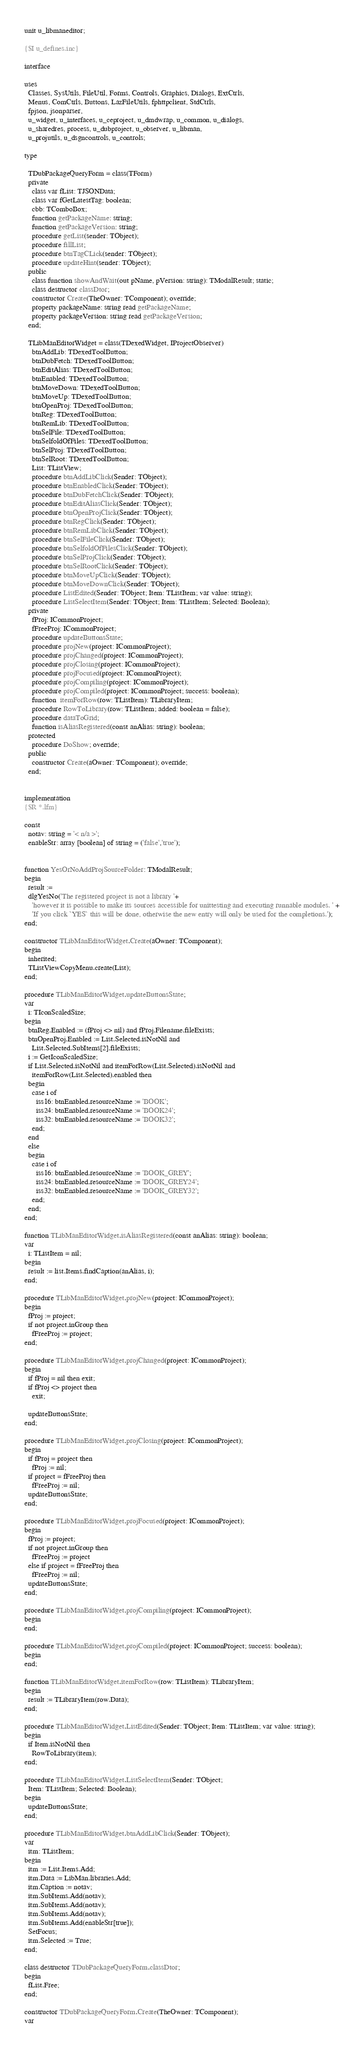Convert code to text. <code><loc_0><loc_0><loc_500><loc_500><_Pascal_>unit u_libmaneditor;

{$I u_defines.inc}

interface

uses
  Classes, SysUtils, FileUtil, Forms, Controls, Graphics, Dialogs, ExtCtrls,
  Menus, ComCtrls, Buttons, LazFileUtils, fphttpclient, StdCtrls,
  fpjson, jsonparser,
  u_widget, u_interfaces, u_ceproject, u_dmdwrap, u_common, u_dialogs,
  u_sharedres, process, u_dubproject, u_observer, u_libman,
  u_projutils, u_dsgncontrols, u_controls;

type

  TDubPackageQueryForm = class(TForm)
  private
    class var fList: TJSONData;
    class var fGetLatestTag: boolean;
    cbb: TComboBox;
    function getPackageName: string;
    function getPackageVersion: string;
    procedure getList(sender: TObject);
    procedure fillList;
    procedure btnTagCLick(sender: TObject);
    procedure updateHint(sender: TObject);
  public
    class function showAndWait(out pName, pVersion: string): TModalResult; static;
    class destructor classDtor;
    constructor Create(TheOwner: TComponent); override;
    property packageName: string read getPackageName;
    property packageVersion: string read getPackageVersion;
  end;

  TLibManEditorWidget = class(TDexedWidget, IProjectObserver)
    btnAddLib: TDexedToolButton;
    btnDubFetch: TDexedToolButton;
    btnEditAlias: TDexedToolButton;
    btnEnabled: TDexedToolButton;
    btnMoveDown: TDexedToolButton;
    btnMoveUp: TDexedToolButton;
    btnOpenProj: TDexedToolButton;
    btnReg: TDexedToolButton;
    btnRemLib: TDexedToolButton;
    btnSelFile: TDexedToolButton;
    btnSelfoldOfFiles: TDexedToolButton;
    btnSelProj: TDexedToolButton;
    btnSelRoot: TDexedToolButton;
    List: TListView;
    procedure btnAddLibClick(Sender: TObject);
    procedure btnEnabledClick(Sender: TObject);
    procedure btnDubFetchClick(Sender: TObject);
    procedure btnEditAliasClick(Sender: TObject);
    procedure btnOpenProjClick(Sender: TObject);
    procedure btnRegClick(Sender: TObject);
    procedure btnRemLibClick(Sender: TObject);
    procedure btnSelFileClick(Sender: TObject);
    procedure btnSelfoldOfFilesClick(Sender: TObject);
    procedure btnSelProjClick(Sender: TObject);
    procedure btnSelRootClick(Sender: TObject);
    procedure btnMoveUpClick(Sender: TObject);
    procedure btnMoveDownClick(Sender: TObject);
    procedure ListEdited(Sender: TObject; Item: TListItem; var value: string);
    procedure ListSelectItem(Sender: TObject; Item: TListItem; Selected: Boolean);
  private
    fProj: ICommonProject;
    fFreeProj: ICommonProject;
    procedure updateButtonsState;
    procedure projNew(project: ICommonProject);
    procedure projChanged(project: ICommonProject);
    procedure projClosing(project: ICommonProject);
    procedure projFocused(project: ICommonProject);
    procedure projCompiling(project: ICommonProject);
    procedure projCompiled(project: ICommonProject; success: boolean);
    function  itemForRow(row: TListItem): TLibraryItem;
    procedure RowToLibrary(row: TListItem; added: boolean = false);
    procedure dataToGrid;
    function isAliasRegistered(const anAlias: string): boolean;
  protected
    procedure DoShow; override;
  public
    constructor Create(aOwner: TComponent); override;
  end;


implementation
{$R *.lfm}

const
  notav: string = '< n/a >';
  enableStr: array [boolean] of string = ('false','true');


function YesOrNoAddProjSourceFolder: TModalResult;
begin
  result :=
  dlgYesNo('The registered project is not a library '+
    'however it is possible to make its sources accessible for unittesting and executing runnable modules. ' +
    'If you click `YES` this will be done, otherwise the new entry will only be used for the completions.');
end;

constructor TLibManEditorWidget.Create(aOwner: TComponent);
begin
  inherited;
  TListViewCopyMenu.create(List);
end;

procedure TLibManEditorWidget.updateButtonsState;
var
  i: TIconScaledSize;
begin
  btnReg.Enabled := (fProj <> nil) and fProj.Filename.fileExists;
  btnOpenProj.Enabled := List.Selected.isNotNil and
    List.Selected.SubItems[2].fileExists;
  i := GetIconScaledSize;
  if List.Selected.isNotNil and itemForRow(List.Selected).isNotNil and
    itemForRow(List.Selected).enabled then
  begin
    case i of
      iss16: btnEnabled.resourceName := 'BOOK';
      iss24: btnEnabled.resourceName := 'BOOK24';
      iss32: btnEnabled.resourceName := 'BOOK32';
    end;
  end
  else
  begin
    case i of
      iss16: btnEnabled.resourceName := 'BOOK_GREY';
      iss24: btnEnabled.resourceName := 'BOOK_GREY24';
      iss32: btnEnabled.resourceName := 'BOOK_GREY32';
    end;
  end;
end;

function TLibManEditorWidget.isAliasRegistered(const anAlias: string): boolean;
var
  i: TListItem = nil;
begin
  result := list.Items.findCaption(anAlias, i);
end;

procedure TLibManEditorWidget.projNew(project: ICommonProject);
begin
  fProj := project;
  if not project.inGroup then
    fFreeProj := project;
end;

procedure TLibManEditorWidget.projChanged(project: ICommonProject);
begin
  if fProj = nil then exit;
  if fProj <> project then
    exit;

  updateButtonsState;
end;

procedure TLibManEditorWidget.projClosing(project: ICommonProject);
begin
  if fProj = project then
    fProj := nil;
  if project = fFreeProj then
    fFreeProj := nil;
  updateButtonsState;
end;

procedure TLibManEditorWidget.projFocused(project: ICommonProject);
begin
  fProj := project;
  if not project.inGroup then
    fFreeProj := project
  else if project = fFreeProj then
    fFreeProj := nil;
  updateButtonsState;
end;

procedure TLibManEditorWidget.projCompiling(project: ICommonProject);
begin
end;

procedure TLibManEditorWidget.projCompiled(project: ICommonProject; success: boolean);
begin
end;

function TLibManEditorWidget.itemForRow(row: TListItem): TLibraryItem;
begin
  result := TLibraryItem(row.Data);
end;

procedure TLibManEditorWidget.ListEdited(Sender: TObject; Item: TListItem; var value: string);
begin
  if Item.isNotNil then
    RowToLibrary(item);
end;

procedure TLibManEditorWidget.ListSelectItem(Sender: TObject;
  Item: TListItem; Selected: Boolean);
begin
  updateButtonsState;
end;

procedure TLibManEditorWidget.btnAddLibClick(Sender: TObject);
var
  itm: TListItem;
begin
  itm := List.Items.Add;
  itm.Data := LibMan.libraries.Add;
  itm.Caption := notav;
  itm.SubItems.Add(notav);
  itm.SubItems.Add(notav);
  itm.SubItems.Add(notav);
  itm.SubItems.Add(enableStr[true]);
  SetFocus;
  itm.Selected := True;
end;

class destructor TDubPackageQueryForm.classDtor;
begin
  fList.Free;
end;

constructor TDubPackageQueryForm.Create(TheOwner: TComponent);
var</code> 